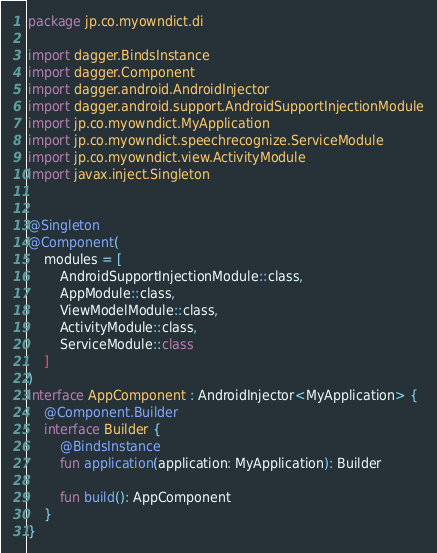Convert code to text. <code><loc_0><loc_0><loc_500><loc_500><_Kotlin_>package jp.co.myowndict.di

import dagger.BindsInstance
import dagger.Component
import dagger.android.AndroidInjector
import dagger.android.support.AndroidSupportInjectionModule
import jp.co.myowndict.MyApplication
import jp.co.myowndict.speechrecognize.ServiceModule
import jp.co.myowndict.view.ActivityModule
import javax.inject.Singleton


@Singleton
@Component(
    modules = [
        AndroidSupportInjectionModule::class,
        AppModule::class,
        ViewModelModule::class,
        ActivityModule::class,
        ServiceModule::class
    ]
)
interface AppComponent : AndroidInjector<MyApplication> {
    @Component.Builder
    interface Builder {
        @BindsInstance
        fun application(application: MyApplication): Builder

        fun build(): AppComponent
    }
}
</code> 